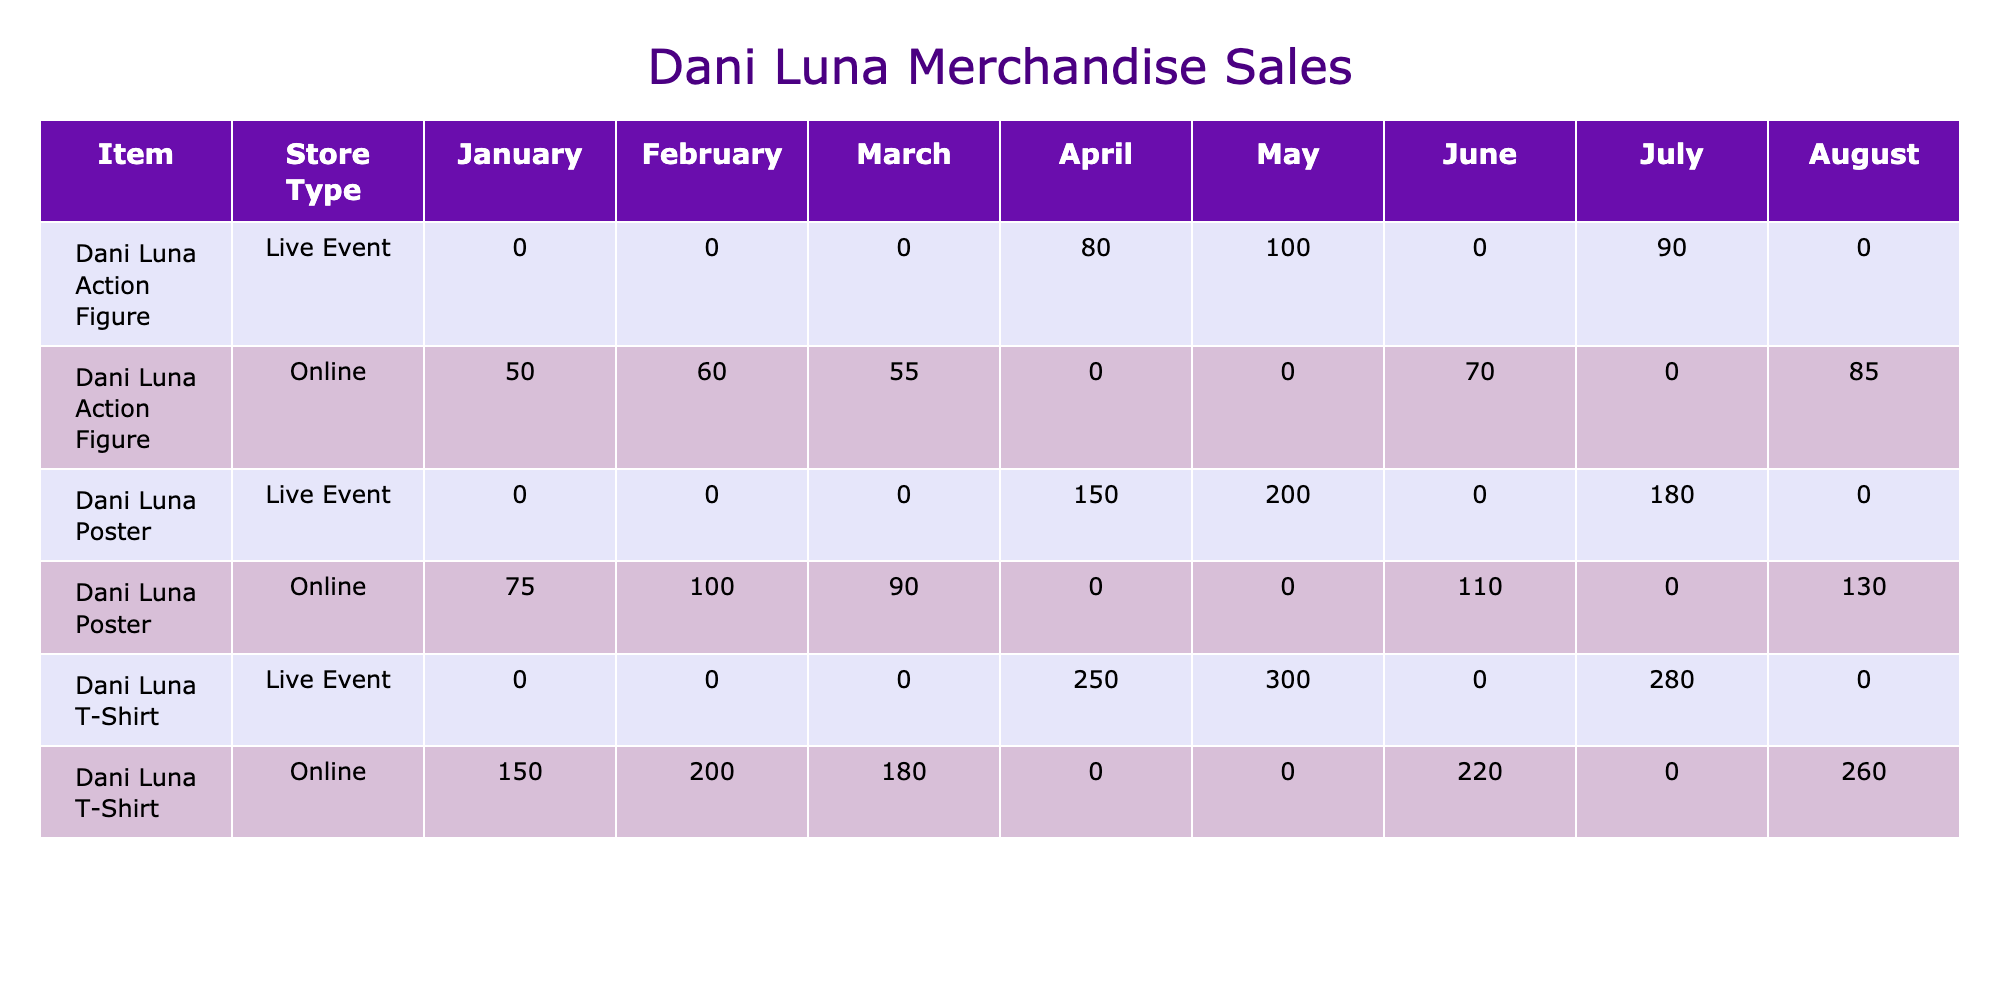What item had the highest sales quantity in January 2023? In January 2023, the "Dani Luna T-Shirt" had a sales quantity of 150, while the "Dani Luna Poster" sold 75 and the "Dani Luna Action Figure" sold 50. Therefore, the highest sales quantity in January 2023 was for the "Dani Luna T-Shirt."
Answer: Dani Luna T-Shirt Which store type sold the most "Dani Luna Poster" items overall? The "Dani Luna Poster" was sold in both Online and Live Event store types. By comparing the total sales across the months, the Online store sold 75 + 100 + 90 = 265 in total, while the Live Event sold 150 + 200 + 180 = 530. Hence, the Live Event store sold the most "Dani Luna Posters" overall.
Answer: Live Event Did sales for the "Dani Luna T-Shirt" increase every month from January to August? A review of the data from January through August shows that the sales quantities were 150, 200, 180, 250, 300, 220, 280, and 260 respectively. This indicates a fluctuation since sales decreased from February to March and from June to August. Therefore, the sales did not increase every month.
Answer: No What was the total revenue generated from "Dani Luna Action Figure" sales in April? In April, the "Dani Luna Action Figure" had a sales quantity of 80, generating revenue of 2000 pounds. Thus, the total revenue for "Dani Luna Action Figure" in April is simply 2000 pounds, derived from that month's figures.
Answer: 2000 What is the average sales quantity of "Dani Luna T-Shirt" over the months available? To find the average, we need to sum the sales quantities for the "Dani Luna T-Shirt" from each month: 150 + 200 + 180 + 250 + 300 + 220 + 280 + 260 = 1840. Then, we divide 1840 by the 8 months to obtain an average of 230.
Answer: 230 Which month had the highest sales quantity for "Dani Luna T-Shirts"? Reviewing the monthly sales quantities, the values are as follows: January (150), February (200), March (180), April (250), May (300), June (220), July (280), and August (260). The highest quantity is in May with 300 units sold.
Answer: May Did Dani Luna sell more merchandise online or at live events? Analyzing the total sales quantities for each channel, Online sales (150 + 200 + 180 + 220 + 260 = 1110) and Live Event sales (250 + 300 + 280 = 830). Since 1110 is greater than 830, more merchandise was sold online.
Answer: Online Which item cumulatively had the least sales quantity over all months? Summing the sales for each item across months: T-Shirt (150 + 200 + 180 + 250 + 300 + 220 + 280 + 260 = 1840), Poster (75 + 100 + 90 + 150 + 200 + 110 + 180 + 130 = 1135), and Action Figure (50 + 60 + 55 + 80 + 100 + 70 + 90 + 85 = 690). The "Dani Luna Action Figure" has the least sales quantity.
Answer: Dani Luna Action Figure 